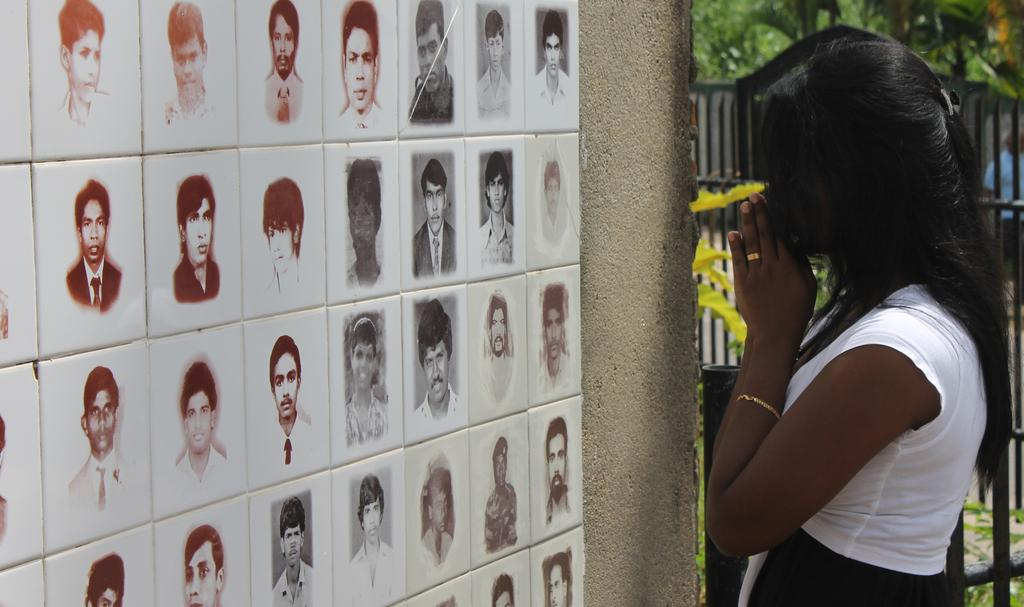What can be seen on the left side of the image? There are photographs on the left side of the image. What is located on the right side of the image? There is a woman on the right side of the image. What structure is present in the image? There is a gate in the image. What type of natural scenery is visible in the background? There are trees in the background of the image. Can you tell me how many butter sculptures are present in the image? There is no butter sculpture present in the image. What type of bird can be seen flying in the image? There is no bird present in the image. 